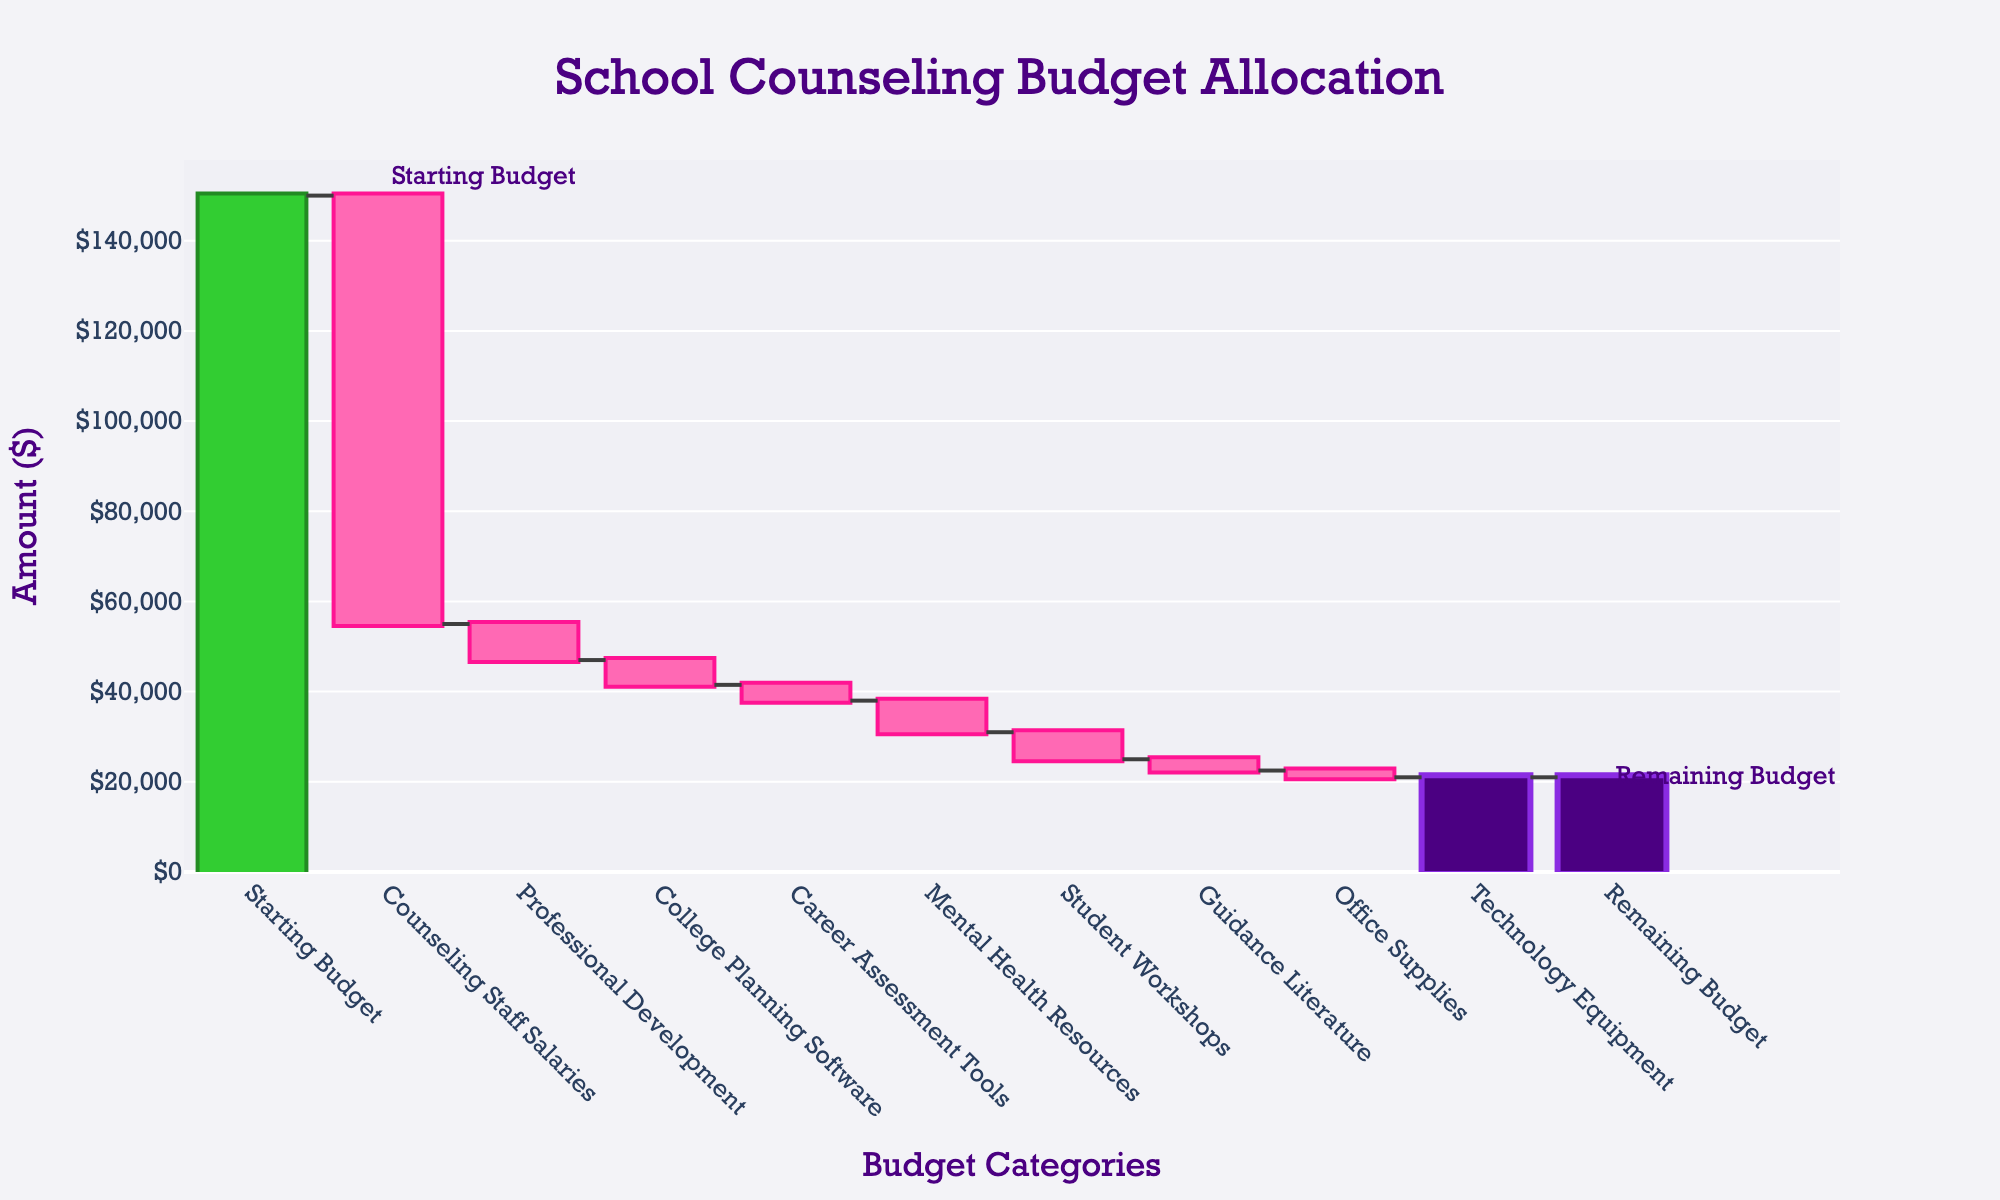What is the total initial budget on the figure? Look at the first bar labeled "Starting Budget," which represents the initial budget amount.
Answer: 150000 How much is allocated for Counseling Staff Salaries? Find the bar labeled "Counseling Staff Salaries" and check its value, which represents the budget allocated for this category.
Answer: 95000 What is the difference between the Starting Budget and the Remaining Budget? Subtract the Remaining Budget from the Starting Budget to find the difference: 150000 - 17000.
Answer: 133000 Which category has the smallest allocation? Compare the lengths of the bars for all expense categories and identify the smallest one, which is "Office Supplies."
Answer: Office Supplies How much is spent on Technology Equipment and Career Assessment Tools combined? Add the amounts for both categories: 4000 (Technology Equipment) + 3500 (Career Assessment Tools).
Answer: 7500 How much more is allocated for Counseling Staff Salaries compared to Professional Development? Subtract the amount for Professional Development from Counseling Staff Salaries: 95000 - 8000.
Answer: 87000 In the figure, which categories are depicted as decreasing budget items? Identify all the bars that represent deductions from the budget.
Answer: Counseling Staff Salaries, Professional Development, College Planning Software, Career Assessment Tools, Mental Health Resources, Student Workshops, Guidance Literature, Office Supplies, Technology Equipment What is the total allocation for mental health-related resources (including Mental Health Resources and Student Workshops)? Add the amounts spent on Mental Health Resources and Student Workshops: 7000 + 6000.
Answer: 13000 How much remaining budget is left after accounting for all expenses? Look at the final bar labeled "Remaining Budget" to find the leftover amount.
Answer: 17000 By how much does the spending on College Planning Software exceed the spending on Office Supplies? Subtract the amount spent on Office Supplies from the amount spent on College Planning Software: 5500 - 1500.
Answer: 4000 